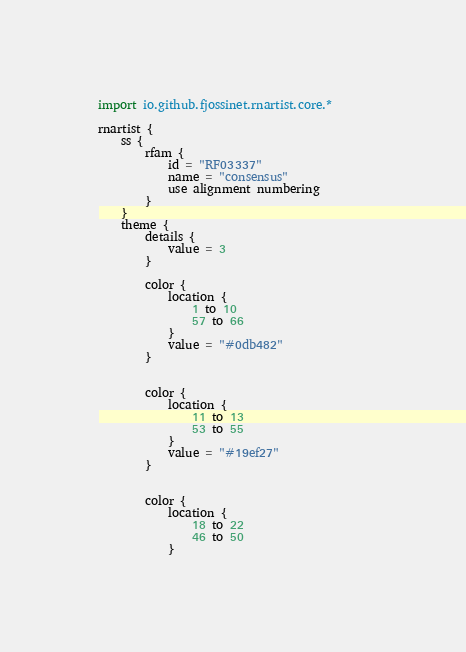Convert code to text. <code><loc_0><loc_0><loc_500><loc_500><_Kotlin_>import io.github.fjossinet.rnartist.core.*      

rnartist {
    ss {
        rfam {
            id = "RF03337"
            name = "consensus"
            use alignment numbering
        }
    }
    theme {
        details { 
            value = 3
        }

        color {
            location {
                1 to 10
                57 to 66
            }
            value = "#0db482"
        }


        color {
            location {
                11 to 13
                53 to 55
            }
            value = "#19ef27"
        }


        color {
            location {
                18 to 22
                46 to 50
            }</code> 